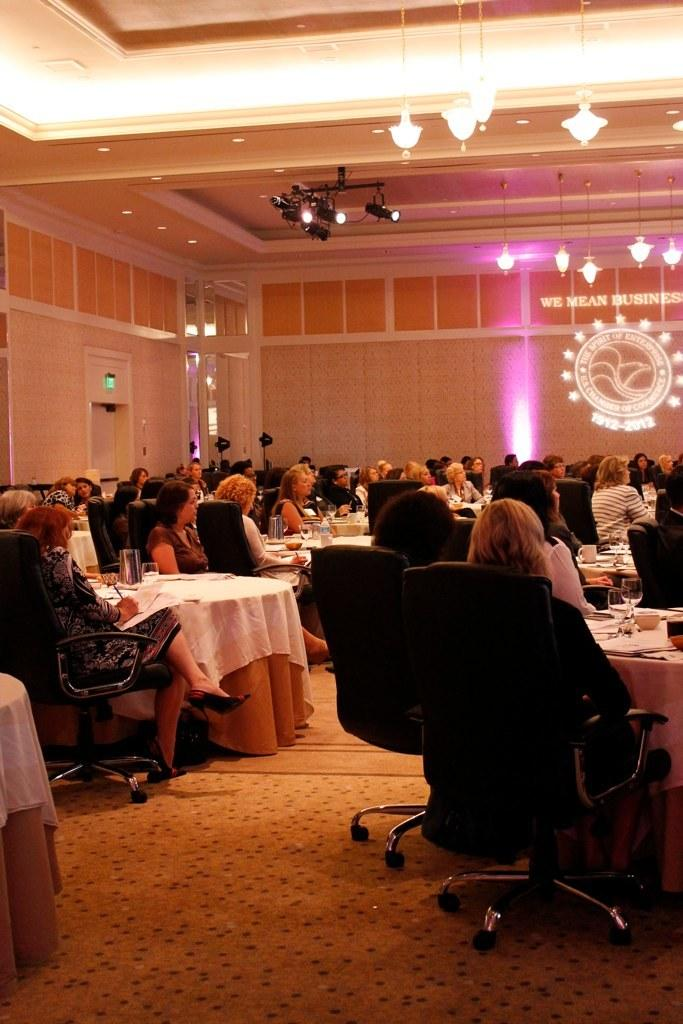How many people are in the image? There is a group of people in the image. What are the people doing in the image? The people are sitting in chairs. Where are the chairs located in relation to the table? The chairs are near a table. What objects can be seen on the table? There is a glass and paper on the table. What type of lighting is present in the background? There is a chandelier and focus lights in the background. What architectural feature is visible in the background? There is a door in the background. What type of dress is the arm wearing in the image? There is no arm or dress present in the image. What type of coach is visible in the background? There is no coach present in the image. 